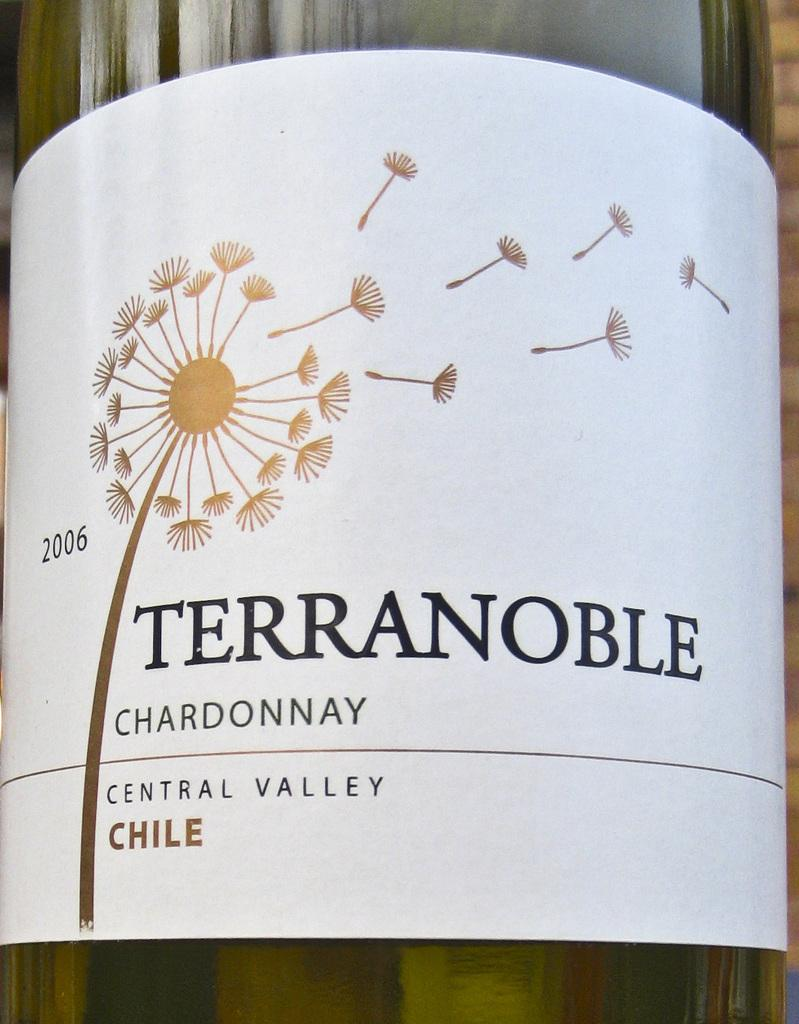Provide a one-sentence caption for the provided image. The brand of Chardonnay shown is made in the Central Valley of Chile. 